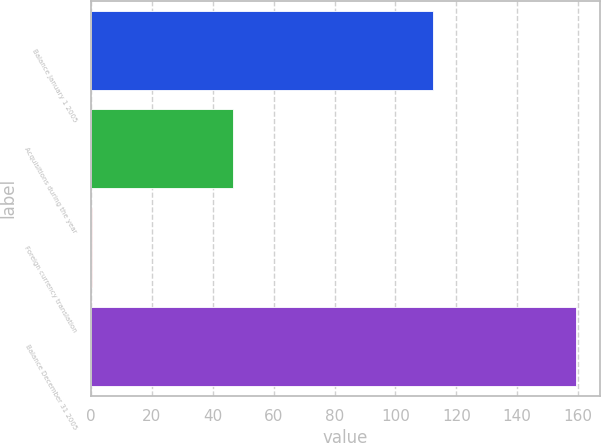Convert chart. <chart><loc_0><loc_0><loc_500><loc_500><bar_chart><fcel>Balance January 1 2005<fcel>Acquisitions during the year<fcel>Foreign currency translation<fcel>Balance December 31 2005<nl><fcel>112.4<fcel>46.6<fcel>0.3<fcel>159.3<nl></chart> 